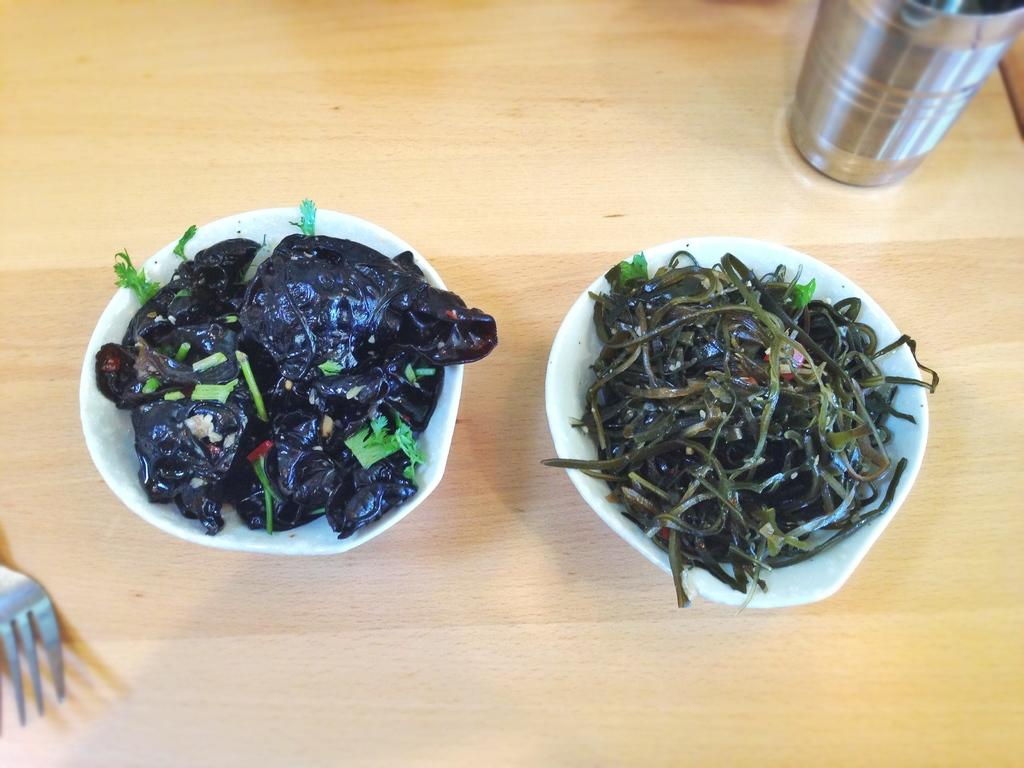What type of glass is in the image? There is a steel glass in the image. What other objects are present on the table? There are bowls and a fork in the image. What is inside the bowls? There are food items in the bowls. Where are all these objects located? All these objects are on a table. What type of shade is covering the table in the image? There is no shade covering the table in the image. What is the aftermath of the meal in the image? The image does not show the aftermath of a meal; it only shows the objects on the table. 